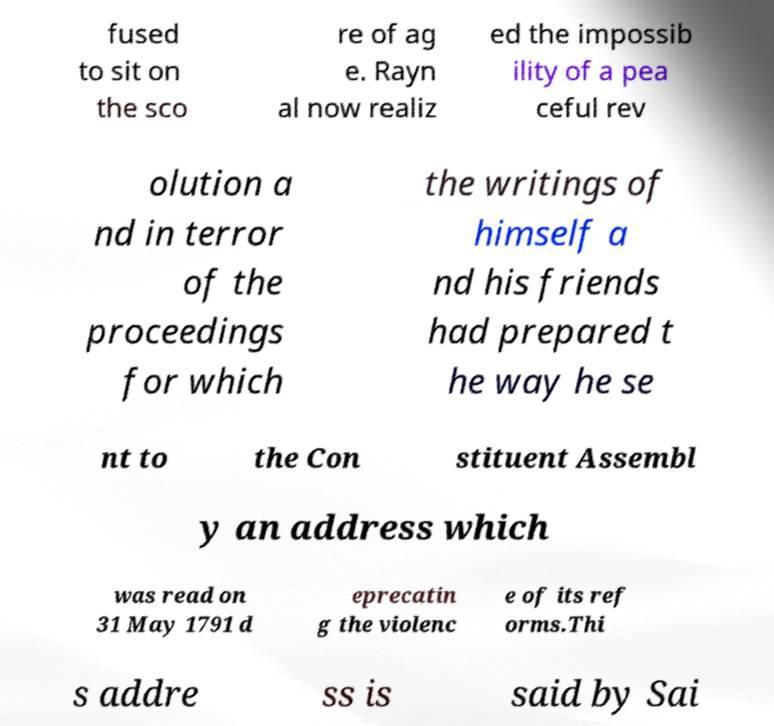Can you accurately transcribe the text from the provided image for me? fused to sit on the sco re of ag e. Rayn al now realiz ed the impossib ility of a pea ceful rev olution a nd in terror of the proceedings for which the writings of himself a nd his friends had prepared t he way he se nt to the Con stituent Assembl y an address which was read on 31 May 1791 d eprecatin g the violenc e of its ref orms.Thi s addre ss is said by Sai 